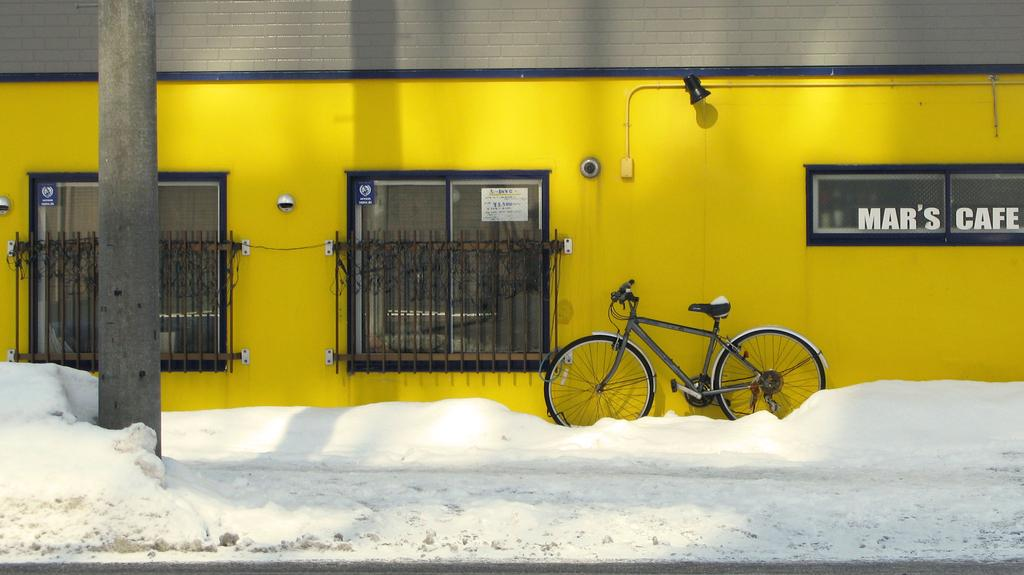What is the main object in the image? There is a bicycle in the image. Where is the bicycle located? The bicycle is on a footpath. What is the condition of the footpath? The footpath is covered with snow. What can be seen in the background of the image? There is a wall in the image. What is the color of the wall? The wall is yellow in color. How many pins are attached to the bicycle in the image? There are no pins attached to the bicycle in the image. What type of fish can be seen swimming in the snow on the footpath? There are no fish present in the image, and fish cannot swim in snow. 